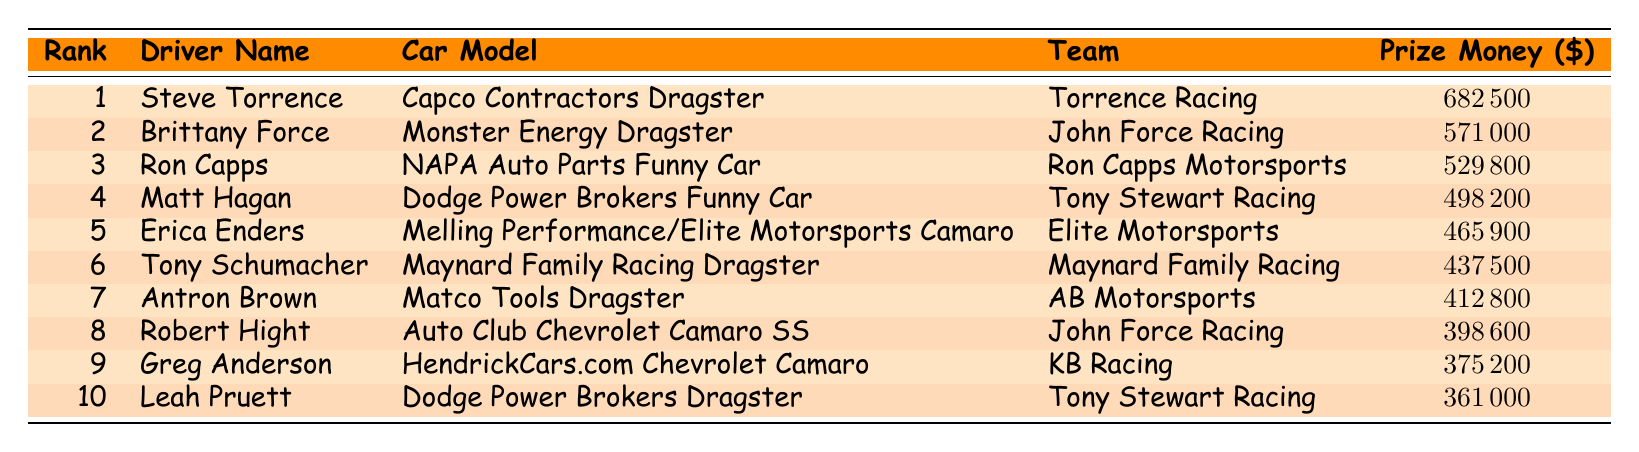What is the car model driven by the driver ranked 1st? The driver ranked 1st is Steve Torrence. According to the table, his car model is the Capco Contractors Dragster.
Answer: Capco Contractors Dragster Which team does Brittany Force race for? Brittany Force is ranked 2nd in the table. The table specifies that she races for John Force Racing.
Answer: John Force Racing How much prize money did Ron Capps earn? Ron Capps is ranked 3rd in the table, and the prize money listed next to his name is $529,800.
Answer: $529800 What is the total prize money earned by the top 5 drivers? We sum the prize money of the top 5 drivers: $682,500 (Steve Torrence) + $571,000 (Brittany Force) + $529,800 (Ron Capps) + $498,200 (Matt Hagan) + $465,900 (Erica Enders) which totals $2,747,400.
Answer: $2747400 Who is the 10th ranked driver? From the table, the 10th ranked driver is Leah Pruett.
Answer: Leah Pruett Is Matt Hagan's car model a Funny Car? Checking the table, Matt Hagan's car model is listed as Dodge Power Brokers Funny Car, which confirms it is indeed a Funny Car.
Answer: Yes Which driver earned the least prize money and how much was it? The table shows that the driver with the least prize money is Leah Pruett, ranked 10th, with $361,000.
Answer: Leah Pruett, $361000 What is the difference in prize money between the 1st and 2nd ranks? The prize money for Steve Torrence is $682,500 and for Brittany Force is $571,000. The difference is $682,500 - $571,000 = $111,500.
Answer: $111500 Calculate the average prize money of the top 10 drivers. Sum the prize money: $682,500 + $571,000 + $529,800 + $498,200 + $465,900 + $437,500 + $412,800 + $398,600 + $375,200 + $361,000 = $4,436,500. Divide by 10 (the number of drivers) gives an average of $443,650.
Answer: $443650 Which team has the highest earning driver? According to the table, Torrence Racing, with Steve Torrence as the driver, has the highest earned prize money at $682,500.
Answer: Torrence Racing 